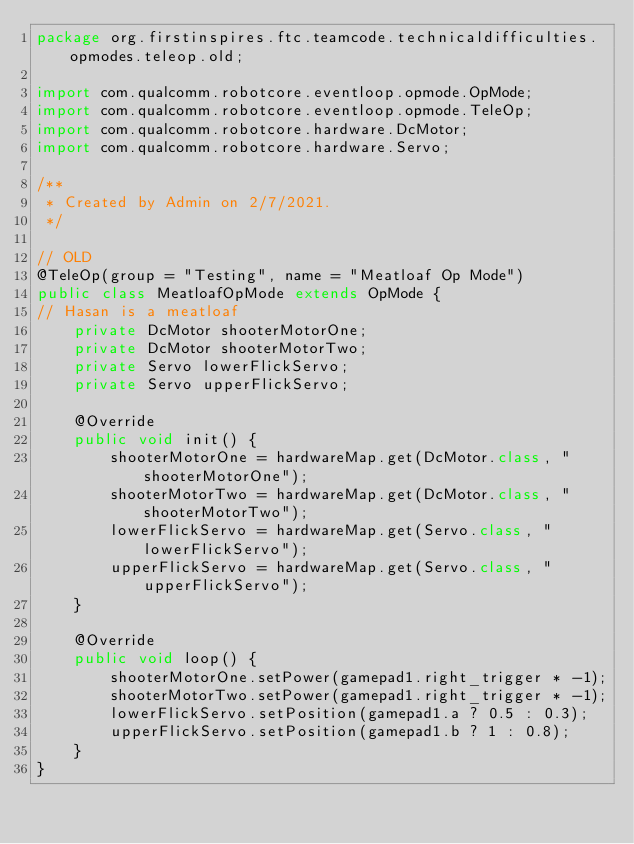Convert code to text. <code><loc_0><loc_0><loc_500><loc_500><_Java_>package org.firstinspires.ftc.teamcode.technicaldifficulties.opmodes.teleop.old;

import com.qualcomm.robotcore.eventloop.opmode.OpMode;
import com.qualcomm.robotcore.eventloop.opmode.TeleOp;
import com.qualcomm.robotcore.hardware.DcMotor;
import com.qualcomm.robotcore.hardware.Servo;

/**
 * Created by Admin on 2/7/2021.
 */

// OLD
@TeleOp(group = "Testing", name = "Meatloaf Op Mode")
public class MeatloafOpMode extends OpMode {
// Hasan is a meatloaf
    private DcMotor shooterMotorOne;
    private DcMotor shooterMotorTwo;
    private Servo lowerFlickServo;
    private Servo upperFlickServo;

    @Override
    public void init() {
        shooterMotorOne = hardwareMap.get(DcMotor.class, "shooterMotorOne");
        shooterMotorTwo = hardwareMap.get(DcMotor.class, "shooterMotorTwo");
        lowerFlickServo = hardwareMap.get(Servo.class, "lowerFlickServo");
        upperFlickServo = hardwareMap.get(Servo.class, "upperFlickServo");
    }

    @Override
    public void loop() {
        shooterMotorOne.setPower(gamepad1.right_trigger * -1);
        shooterMotorTwo.setPower(gamepad1.right_trigger * -1);
        lowerFlickServo.setPosition(gamepad1.a ? 0.5 : 0.3);
        upperFlickServo.setPosition(gamepad1.b ? 1 : 0.8);
    }
}
</code> 